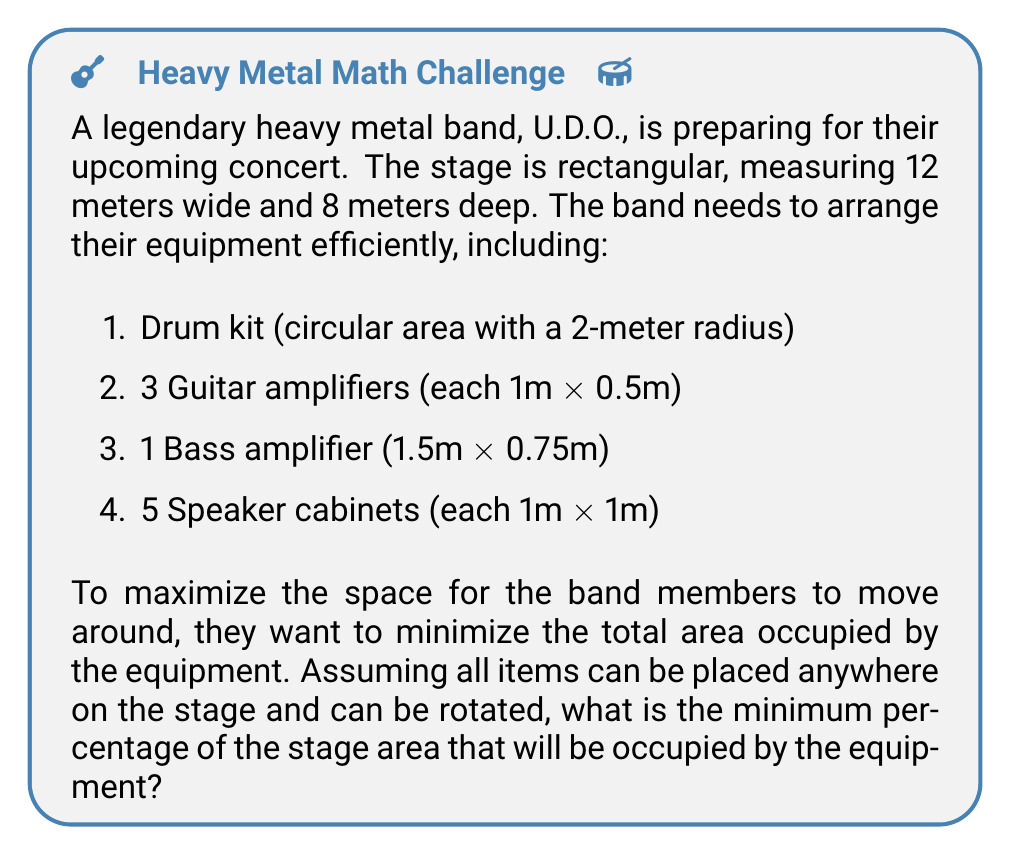Help me with this question. Let's approach this problem step-by-step:

1. Calculate the total stage area:
   $$A_{stage} = 12m \times 8m = 96m^2$$

2. Calculate the areas of each equipment:
   - Drum kit: $$A_{drum} = \pi r^2 = \pi (2m)^2 = 4\pi m^2$$
   - Guitar amplifiers: $$A_{guitar} = 3 \times (1m \times 0.5m) = 1.5m^2$$
   - Bass amplifier: $$A_{bass} = 1.5m \times 0.75m = 1.125m^2$$
   - Speaker cabinets: $$A_{speakers} = 5 \times (1m \times 1m) = 5m^2$$

3. Calculate the total area of all equipment:
   $$A_{total} = A_{drum} + A_{guitar} + A_{bass} + A_{speakers}$$
   $$A_{total} = 4\pi m^2 + 1.5m^2 + 1.125m^2 + 5m^2$$
   $$A_{total} = 4\pi m^2 + 7.625m^2$$
   $$A_{total} \approx 20.1938m^2$$

4. Calculate the percentage of the stage occupied:
   $$\text{Percentage} = \frac{A_{total}}{A_{stage}} \times 100\%$$
   $$\text{Percentage} = \frac{20.1938m^2}{96m^2} \times 100\% \approx 21.04\%$$

Therefore, the minimum percentage of the stage area that will be occupied by the equipment is approximately 21.04%.
Answer: 21.04% 